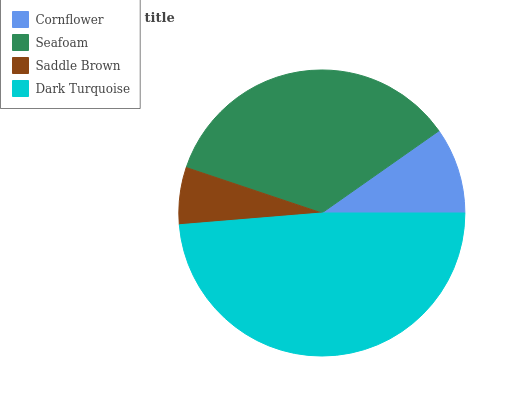Is Saddle Brown the minimum?
Answer yes or no. Yes. Is Dark Turquoise the maximum?
Answer yes or no. Yes. Is Seafoam the minimum?
Answer yes or no. No. Is Seafoam the maximum?
Answer yes or no. No. Is Seafoam greater than Cornflower?
Answer yes or no. Yes. Is Cornflower less than Seafoam?
Answer yes or no. Yes. Is Cornflower greater than Seafoam?
Answer yes or no. No. Is Seafoam less than Cornflower?
Answer yes or no. No. Is Seafoam the high median?
Answer yes or no. Yes. Is Cornflower the low median?
Answer yes or no. Yes. Is Cornflower the high median?
Answer yes or no. No. Is Dark Turquoise the low median?
Answer yes or no. No. 